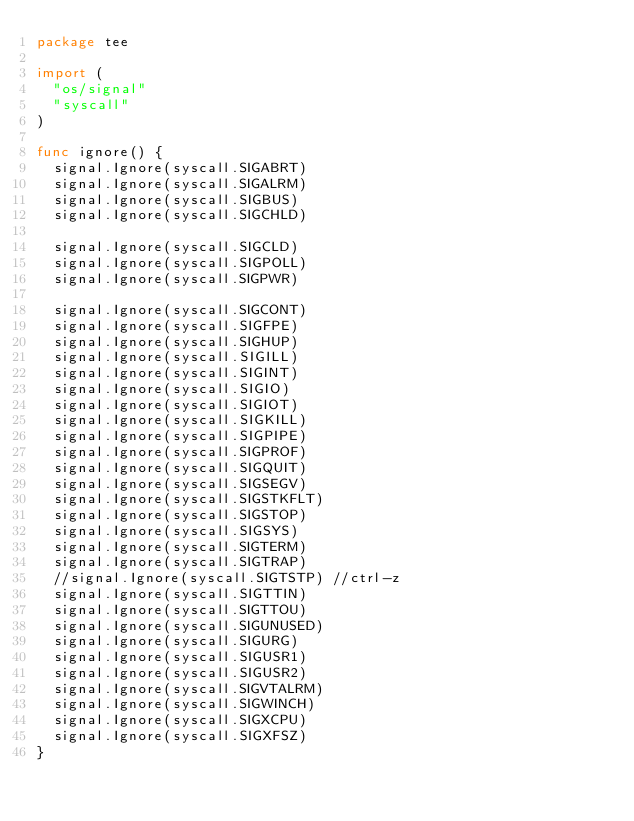Convert code to text. <code><loc_0><loc_0><loc_500><loc_500><_Go_>package tee

import (
	"os/signal"
	"syscall"
)

func ignore() {
	signal.Ignore(syscall.SIGABRT)
	signal.Ignore(syscall.SIGALRM)
	signal.Ignore(syscall.SIGBUS)
	signal.Ignore(syscall.SIGCHLD)

	signal.Ignore(syscall.SIGCLD)
	signal.Ignore(syscall.SIGPOLL)
	signal.Ignore(syscall.SIGPWR)

	signal.Ignore(syscall.SIGCONT)
	signal.Ignore(syscall.SIGFPE)
	signal.Ignore(syscall.SIGHUP)
	signal.Ignore(syscall.SIGILL)
	signal.Ignore(syscall.SIGINT)
	signal.Ignore(syscall.SIGIO)
	signal.Ignore(syscall.SIGIOT)
	signal.Ignore(syscall.SIGKILL)
	signal.Ignore(syscall.SIGPIPE)
	signal.Ignore(syscall.SIGPROF)
	signal.Ignore(syscall.SIGQUIT)
	signal.Ignore(syscall.SIGSEGV)
	signal.Ignore(syscall.SIGSTKFLT)
	signal.Ignore(syscall.SIGSTOP)
	signal.Ignore(syscall.SIGSYS)
	signal.Ignore(syscall.SIGTERM)
	signal.Ignore(syscall.SIGTRAP)
	//signal.Ignore(syscall.SIGTSTP) //ctrl-z
	signal.Ignore(syscall.SIGTTIN)
	signal.Ignore(syscall.SIGTTOU)
	signal.Ignore(syscall.SIGUNUSED)
	signal.Ignore(syscall.SIGURG)
	signal.Ignore(syscall.SIGUSR1)
	signal.Ignore(syscall.SIGUSR2)
	signal.Ignore(syscall.SIGVTALRM)
	signal.Ignore(syscall.SIGWINCH)
	signal.Ignore(syscall.SIGXCPU)
	signal.Ignore(syscall.SIGXFSZ)
}
</code> 